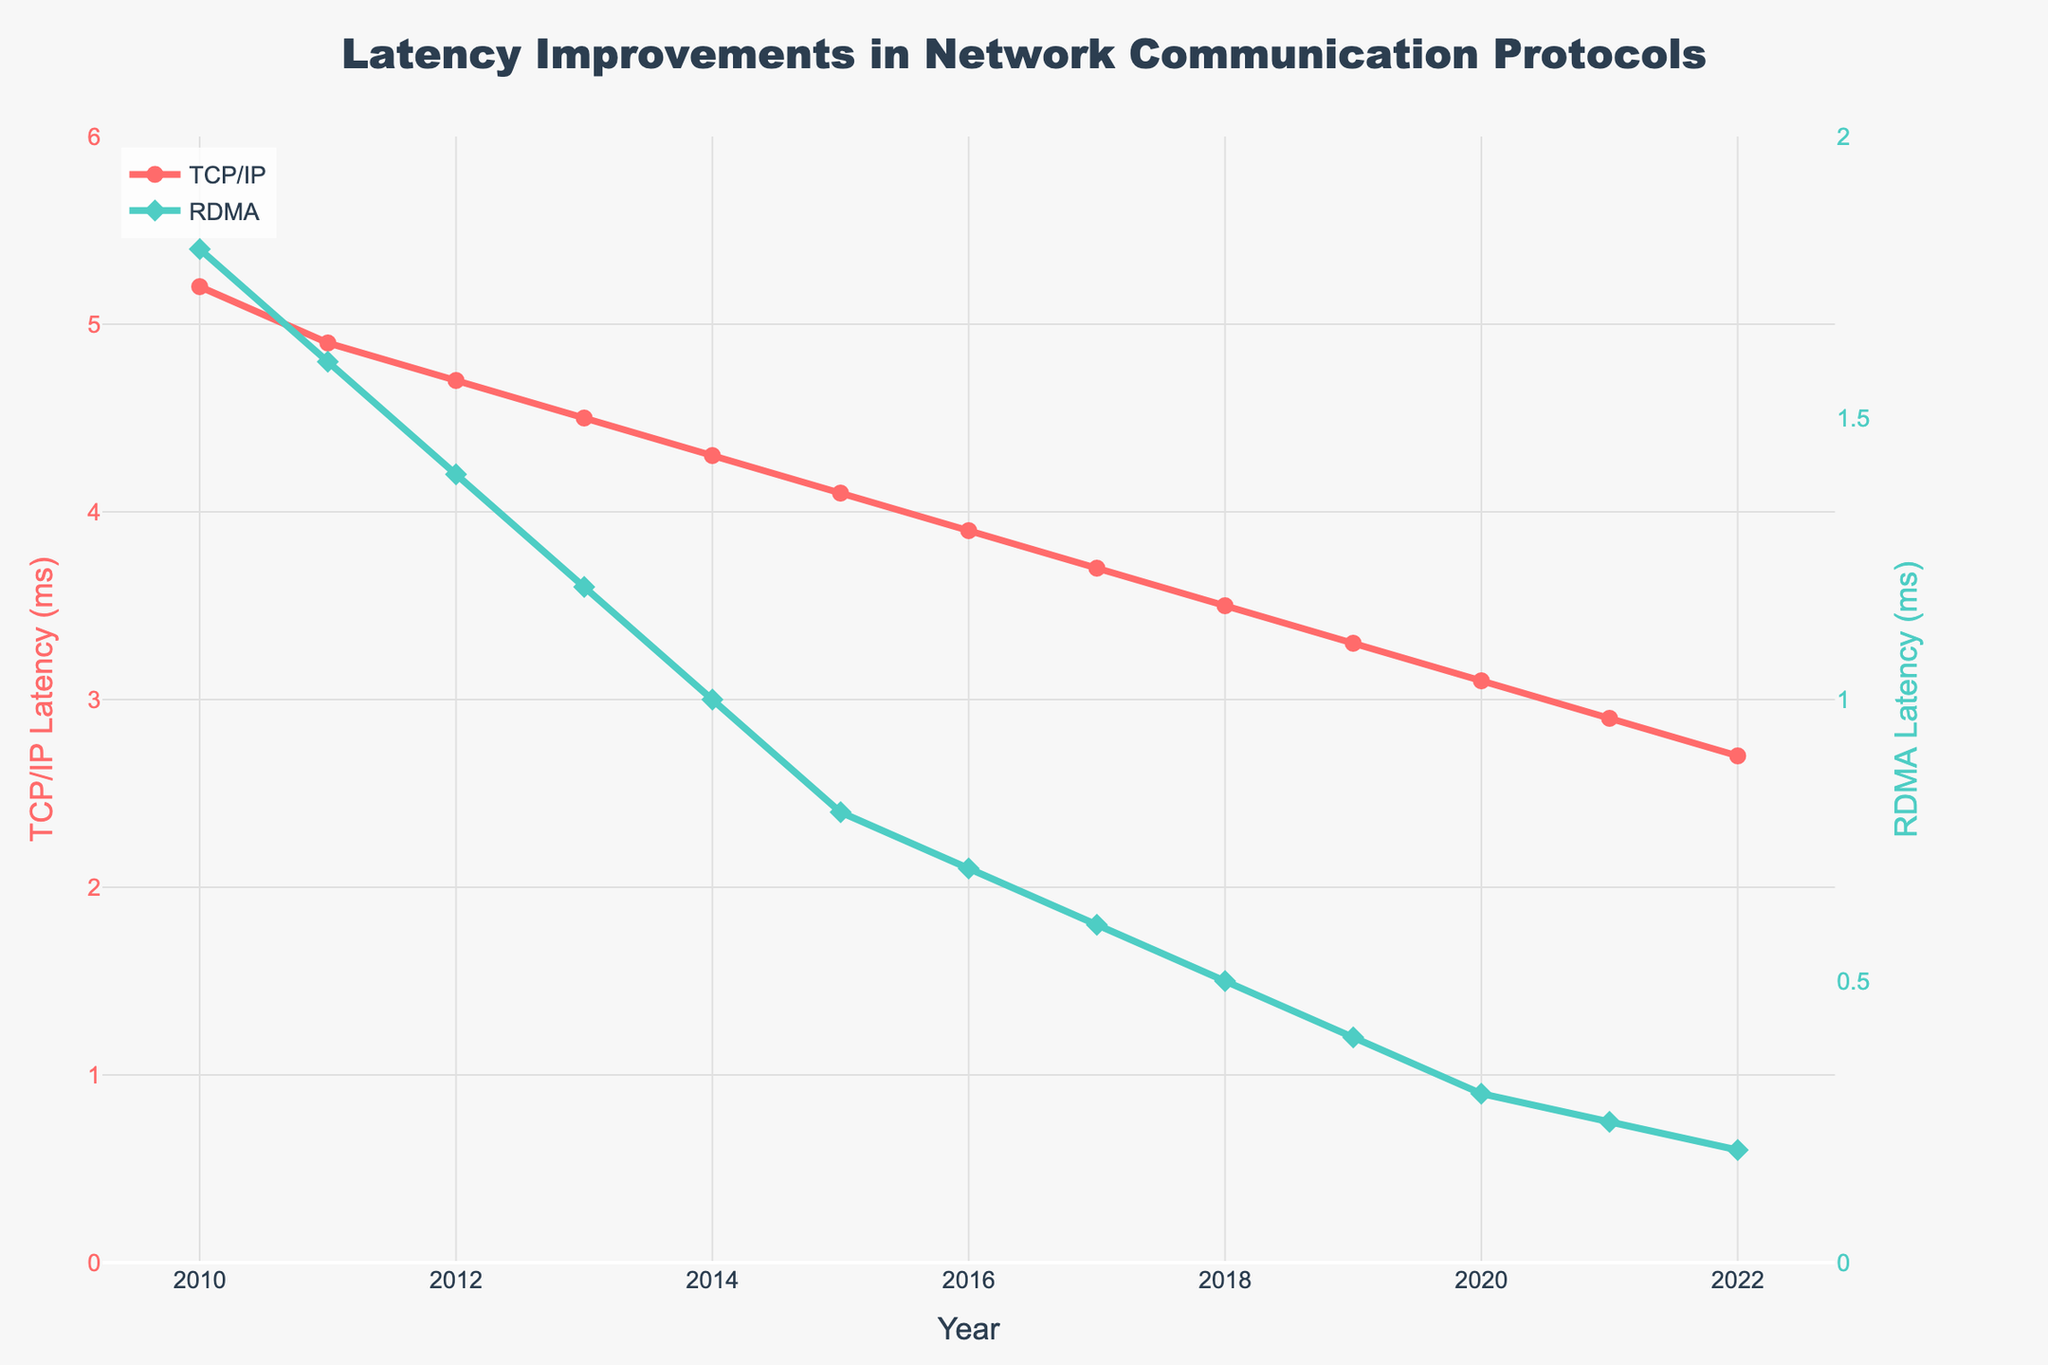What is the latency improvement for TCP/IP from 2010 to 2022? To find the latency improvement, subtract the 2022 latency from the 2010 latency for TCP/IP. From the chart, TCP/IP latency in 2010 is 5.2 ms and in 2022 is 2.7 ms. So, the improvement is 5.2 - 2.7 = 2.5 ms.
Answer: 2.5 ms Which protocol showed a greater latency improvement between 2010 and 2022? Calculate the latency improvement for both TCP/IP and RDMA by subtracting the 2022 values from the 2010 values. TCP/IP improvement: 5.2 ms - 2.7 ms = 2.5 ms; RDMA improvement: 1.8 ms - 0.2 ms = 1.6 ms. Compare the two improvements.
Answer: TCP/IP What is the average latency reduction per year for RDMA between 2010 and 2022? Subtract the 2010 latency from the 2022 latency for RDMA and divide by the number of years (2022 - 2010 = 12 years). RDMA improvement: 1.8 ms - 0.2 ms = 1.6 ms. Average reduction per year: 1.6 ms / 12 years = 0.1333 ms/year.
Answer: 0.1333 ms/year In which year did the TCP/IP latency first drop below 4 ms? Inspect the TCP/IP latency values for each year and find the first year where latency is below 4 ms. From the chart, the latency drops below 4 ms in 2016 (3.9 ms).
Answer: 2016 Compare the latencies of TCP/IP and RDMA in 2015. Which protocol had lower latency? Look at the values for both protocols in 2015. TCP/IP latency is 4.1 ms and RDMA latency is 0.8 ms. RDMA has a lower latency.
Answer: RDMA What is the difference in latency between TCP/IP and RDMA in 2022? Subtract the RDMA latency from the TCP/IP latency in 2022. TCP/IP latency in 2022 is 2.7 ms and RDMA latency in 2022 is 0.2 ms. Difference: 2.7 ms - 0.2 ms = 2.5 ms.
Answer: 2.5 ms How much faster is RDMA compared to TCP/IP in 2021? Find the ratio of latencies by dividing the TCP/IP latency by the RDMA latency for 2021. TCP/IP latency in 2021 is 2.9 ms and RDMA latency in 2021 is 0.25 ms. Ratio: 2.9 / 0.25 = 11.6 times.
Answer: 11.6 times What is the overall trend of TCP/IP latency from 2010 to 2022? Examine the TCP/IP latency values from 2010 to 2022. The values decrease consistently each year, indicating a downwards trend.
Answer: Downwards trend How does the rate of latency reduction differ between TCP/IP and RDMA? Compare the average annual reduction for both protocols. TCP/IP: (5.2 - 2.7) ms / 12 years = 0.2083 ms/year; RDMA: (1.8 - 0.2) ms / 12 years = 0.1333 ms/year. TCP/IP has a higher average annual reduction.
Answer: TCP/IP reduces faster 